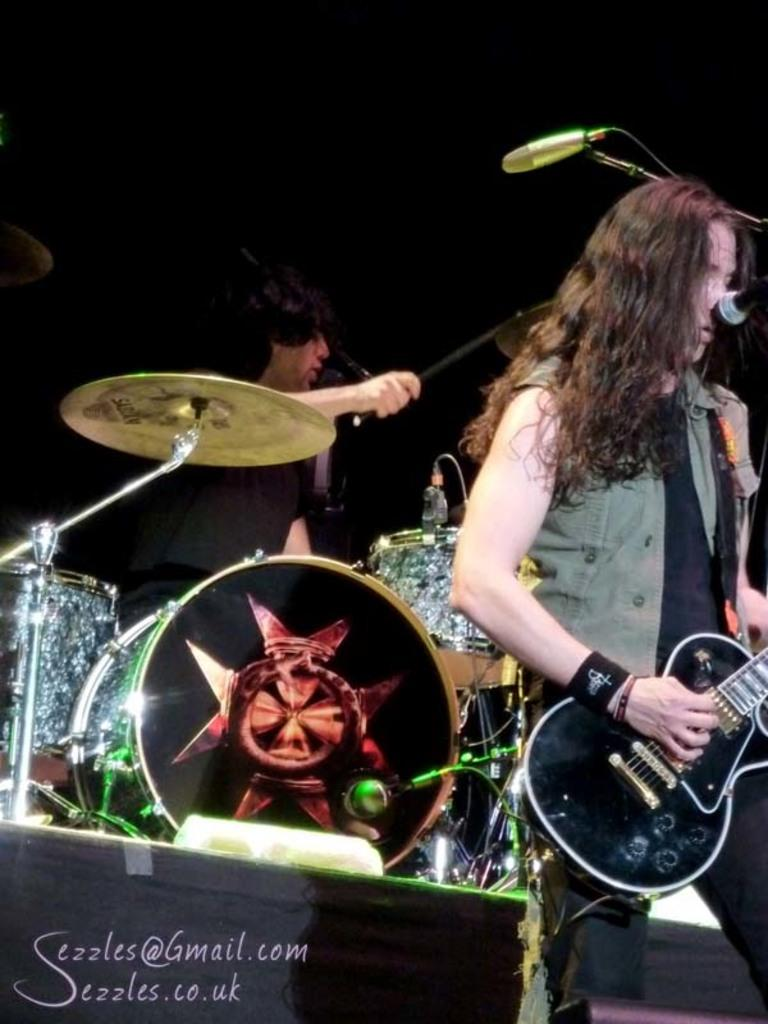What is the woman in the image doing? The woman is standing and playing a guitar in the image. What object is in front of the woman? There is a microphone in front of the woman. What is the man in the background of the image doing? The man is playing drums in the background of the image. What color is the dress the man is wearing? The man is wearing a black dress. Can you tell me how many doors are visible in the image? There are no doors visible in the image. What type of angle is the woman playing the guitar at in the image? The angle at which the woman is playing the guitar is not mentioned in the image, and therefore cannot be determined. 